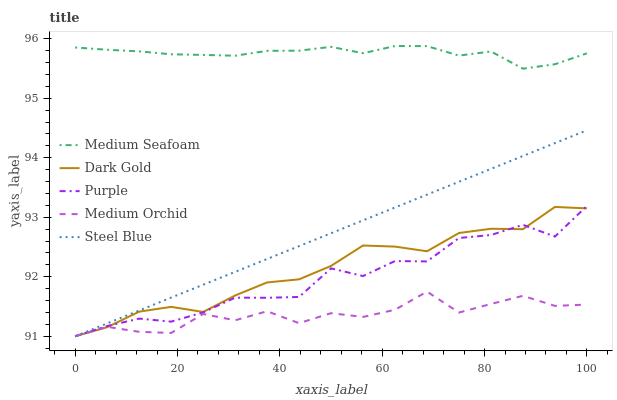Does Steel Blue have the minimum area under the curve?
Answer yes or no. No. Does Steel Blue have the maximum area under the curve?
Answer yes or no. No. Is Medium Orchid the smoothest?
Answer yes or no. No. Is Medium Orchid the roughest?
Answer yes or no. No. Does Medium Seafoam have the lowest value?
Answer yes or no. No. Does Steel Blue have the highest value?
Answer yes or no. No. Is Steel Blue less than Medium Seafoam?
Answer yes or no. Yes. Is Medium Seafoam greater than Purple?
Answer yes or no. Yes. Does Steel Blue intersect Medium Seafoam?
Answer yes or no. No. 